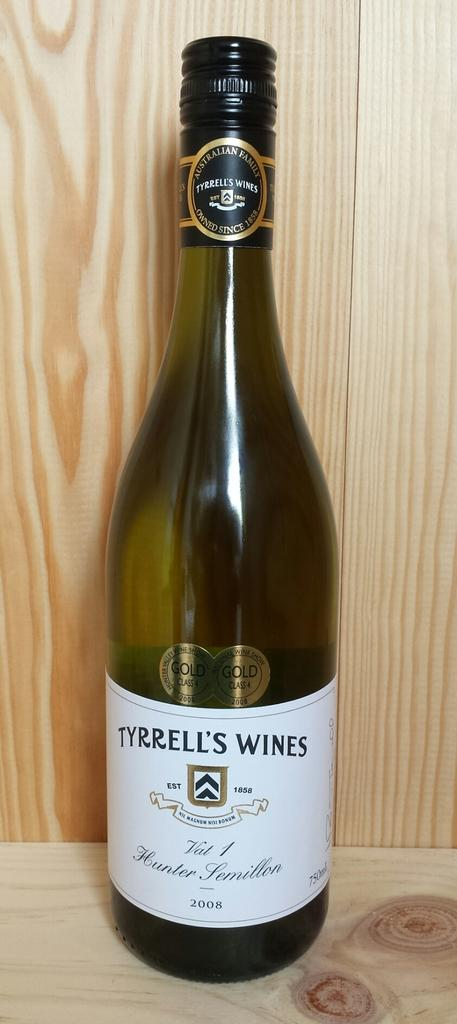<image>
Provide a brief description of the given image. A bottle of wine by Terrell's Wine that took the Gold at the National Wine Show in 2008. 